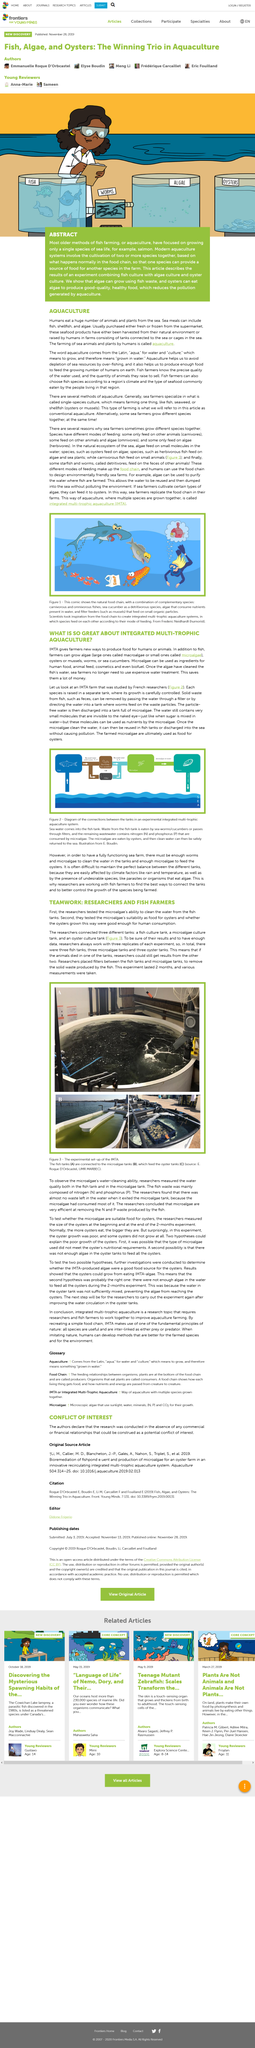Outline some significant characteristics in this image. Single-species culture is the specialization of sea farmers, who generally focus on raising a specific type of seafood in their aquatic farms. The first step that researchers take is to evaluate the capacity of microalgae to purify water from fish tanks. The arrow in the blue box to the left of Figure 2 represents the flow of sea water into the fish tank. Detritivores are starfish and worms that feed on the feces of other animals. Figure 1 illustrates the natural food chain, featuring a combination of complementary species that coexist harmoniously in their ecosystem. 